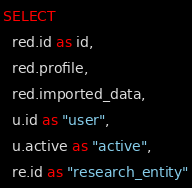<code> <loc_0><loc_0><loc_500><loc_500><_SQL_>SELECT
  red.id as id,
  red.profile,
  red.imported_data,
  u.id as "user",
  u.active as "active",
  re.id as "research_entity"</code> 